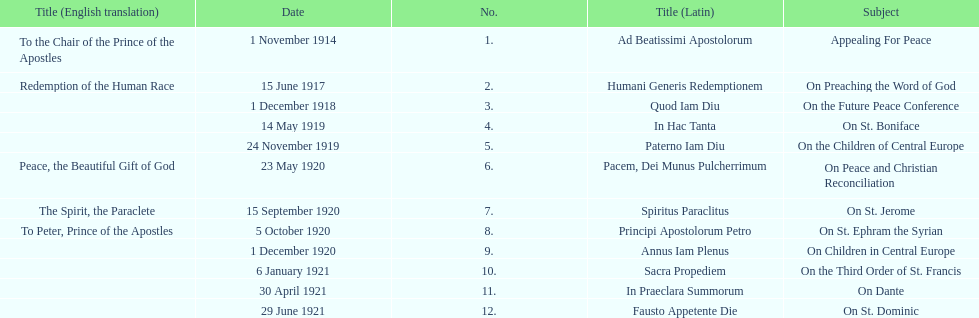What are the number of titles with a date of november? 2. 